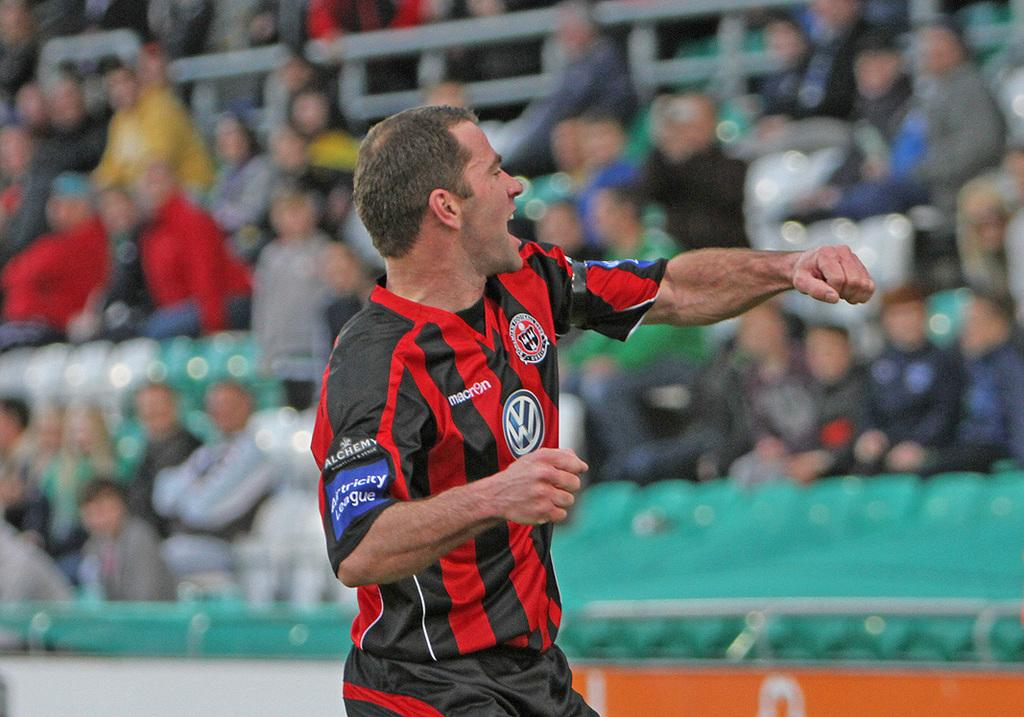<image>
Relay a brief, clear account of the picture shown. Soccer player wearing a jersey that says "Alchemy" on it. 